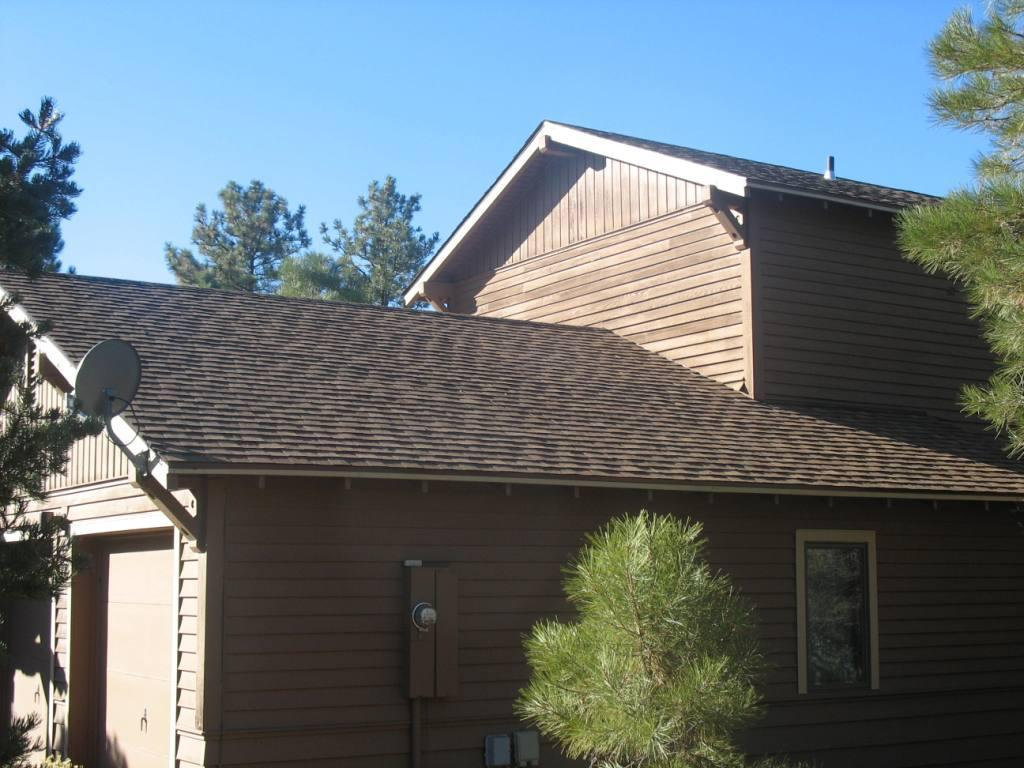What type of natural elements can be seen in the image? There are trees in the image. What type of man-made structures are present in the image? There are buildings in the image. Can you describe any specific features on the buildings? There is a dish TV antenna on the roof of a building. What is the condition of the sky in the image? The sky is clear in the image. Can you tell me how many bees are flying around the trees in the image? There are no bees visible in the image; it only features trees and buildings. What type of show is being broadcasted on the dish TV antenna in the image? The image does not provide any information about the content being broadcasted on the dish TV antenna. 